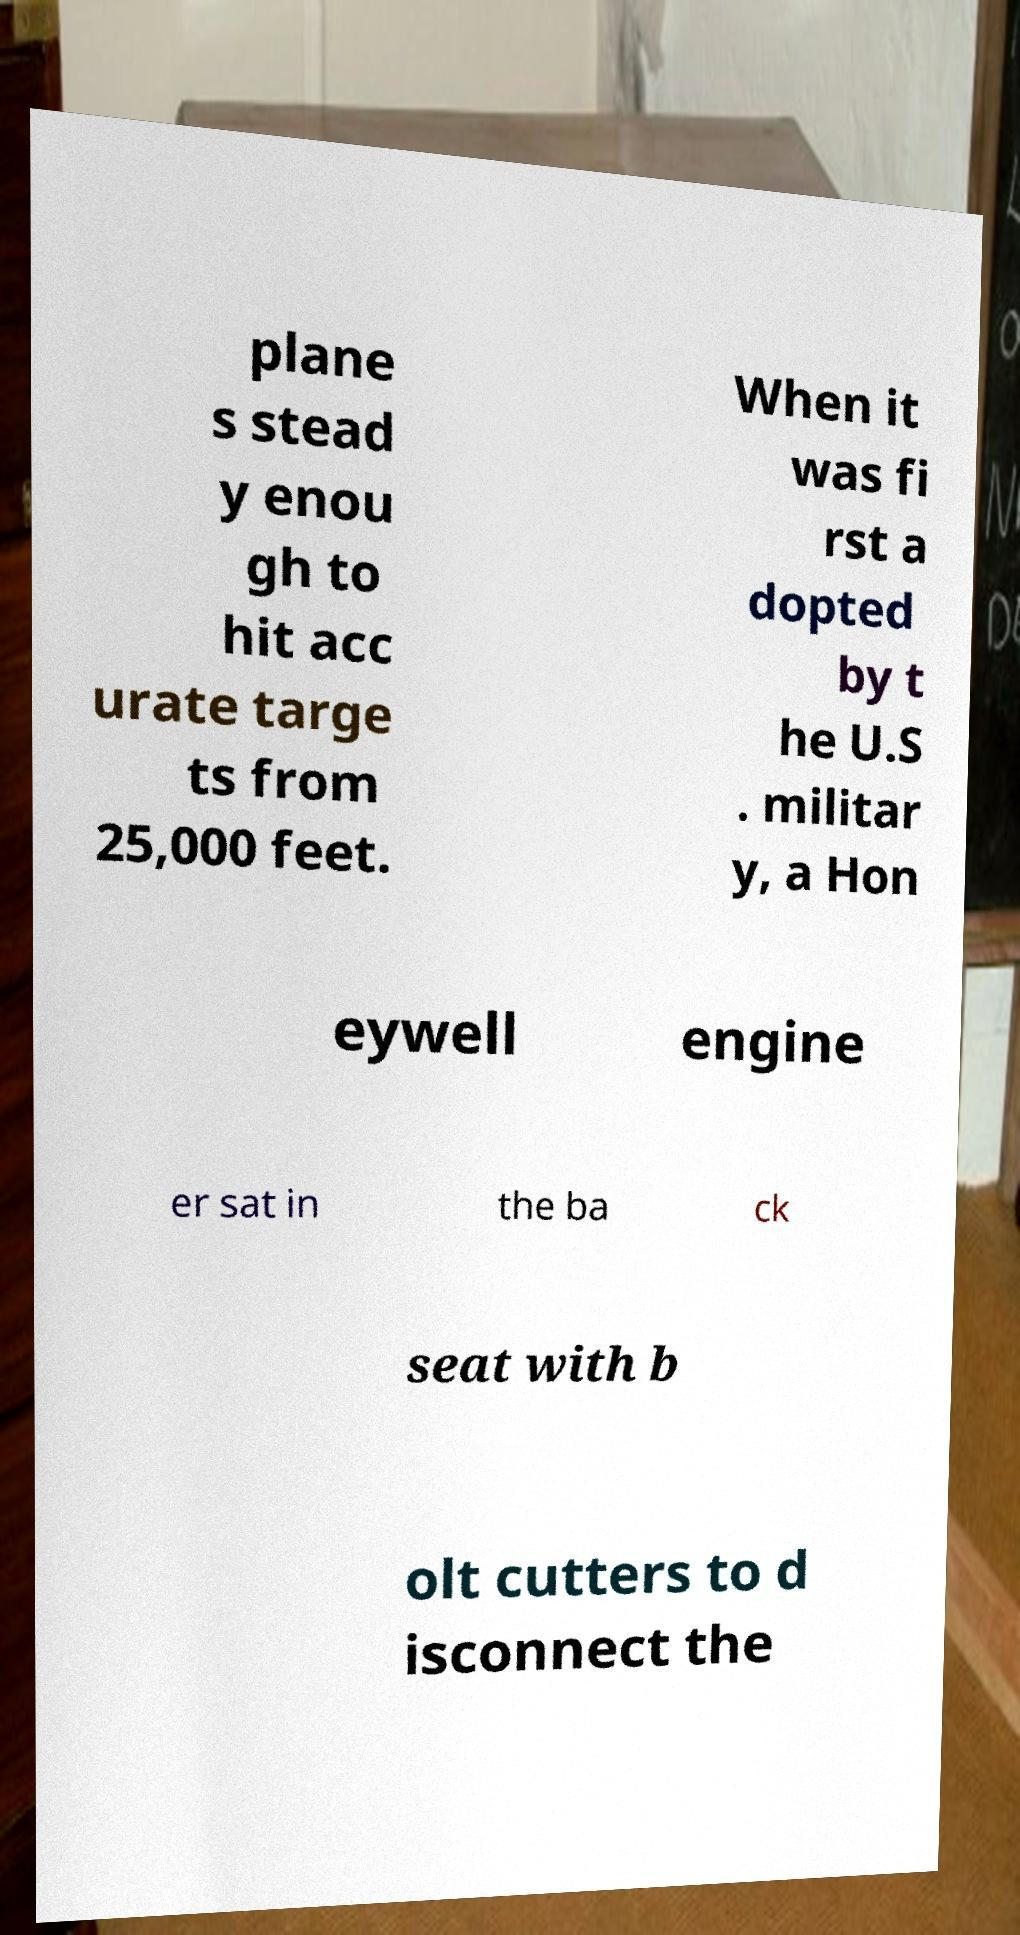Can you accurately transcribe the text from the provided image for me? plane s stead y enou gh to hit acc urate targe ts from 25,000 feet. When it was fi rst a dopted by t he U.S . militar y, a Hon eywell engine er sat in the ba ck seat with b olt cutters to d isconnect the 